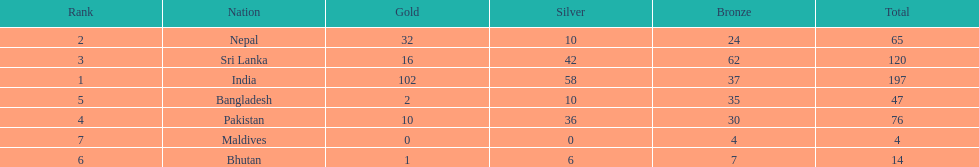What was the only nation to win less than 10 medals total? Maldives. 